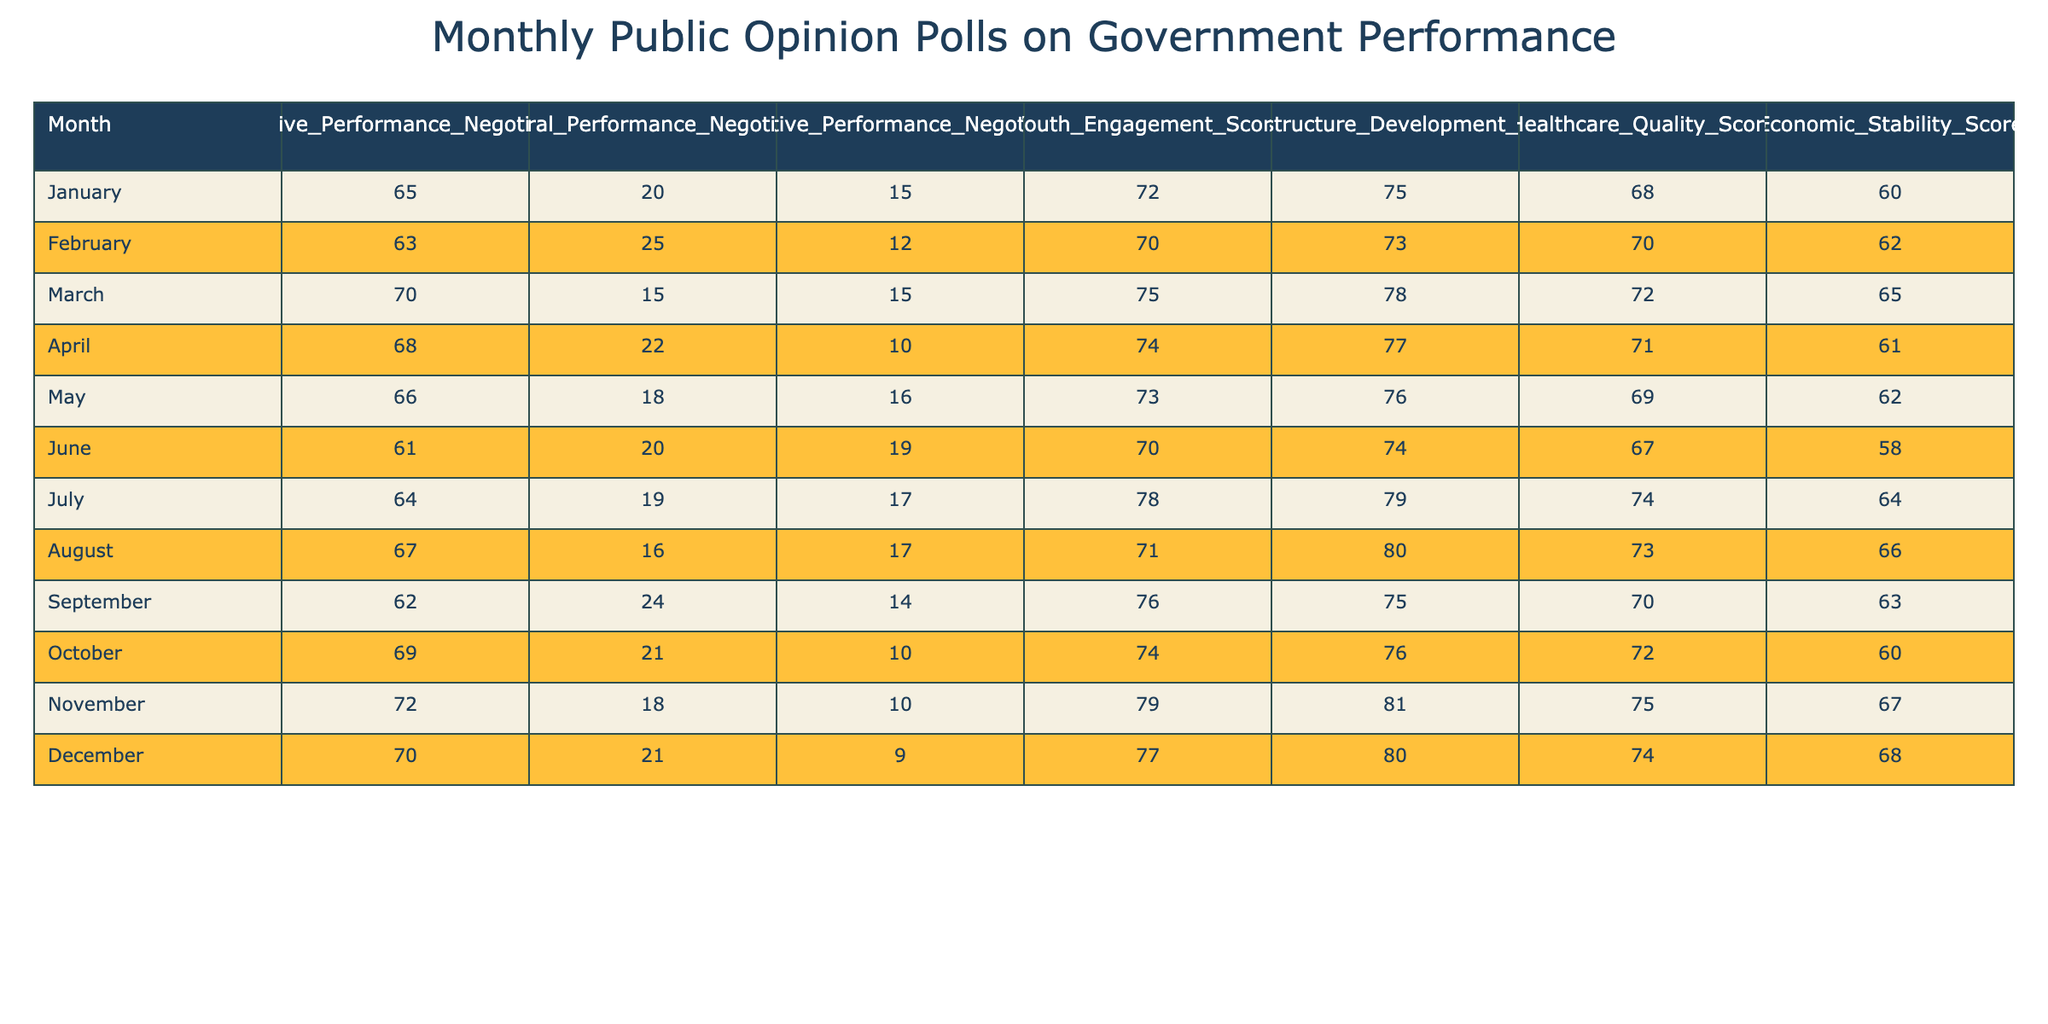What was the highest Positive Performance Negotiation score recorded in the year? Looking through the Positive Performance Negotiation column, the highest score of 72 occurs in November.
Answer: 72 In which month did the Negative Performance Negotiation score reach its lowest point, and what was that score? By examining the Negative Performance Negotiation column, the lowest score is 9 in December.
Answer: December, 9 What is the average Youth Engagement Score for the first half of the year (January to June)? To calculate the average, sum the scores for the first six months: (72 + 70 + 75 + 74 + 73 + 70) = 434. Then divide by the number of months, which is 6. Thus, 434/6 = 72.33.
Answer: 72.33 Did the Healthcare Quality Score in September exceed the average for the entire year? The Healthcare Quality Scores for the months are: 68, 70, 72, 71, 69, 67, 74, 73, 70, 72, 75, 74. The average is calculated by summing these scores (total is  870) and dividing by 12, leading to an average of 72.5. September had a score of 70, which is less than 72.5.
Answer: No What is the difference in the Infrastructure Development Score between April and November? The Infrastructure Development Score for April is 77, and for November, it is 81. Thus, the difference is 81 - 77 = 4.
Answer: 4 Were there any months where the Negative Performance Negotiation score was lower than the Youth Engagement Score? By checking each month, it can be seen that the Negative scores in December (9), November (10), October (10), and April (10) were all lower than the corresponding Youth Engagement Scores (77, 79, 74, 74) in those months.
Answer: Yes What was the trend of Economic Stability Score from January to December? Analyzing the Economic Stability Score from January (60) to December (68), there is a general increase with minor fluctuations: 60, 62, 65, 61, 62, 58, 64, 66, 63, 60, 67, 68, indicating an upward trend overall.
Answer: Increasing What was the maximum score recorded for any Performance Negotiation type in a single month? By reviewing all the performance negotiation scores: Positive (72 in November), Neutral (25 in February), and Negative (19 in June), the maximum is 72 in November.
Answer: 72 